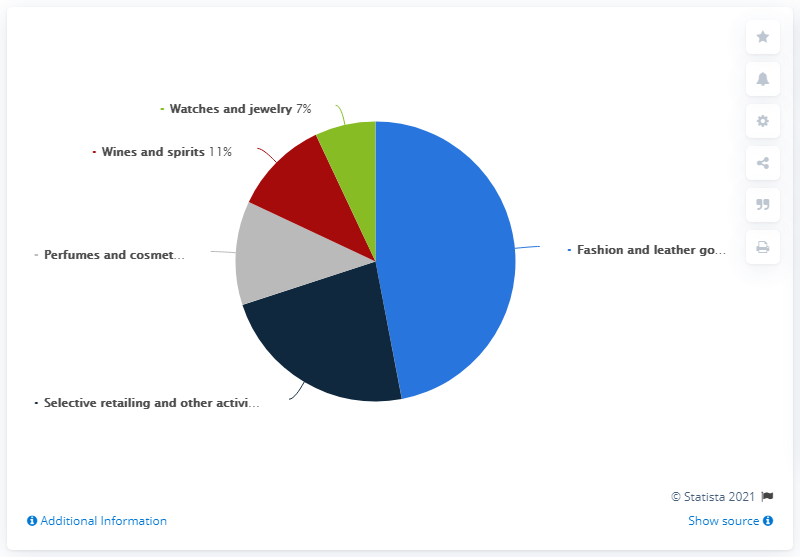Highlight a few significant elements in this photo. The LVMH Group generated the highest revenue share in 2020 from the Fashion and Leather Goods business segment worldwide. The difference between the first and second lowest revenue share of the LVMH Group worldwide in 2020, by business segment, was 4%. 